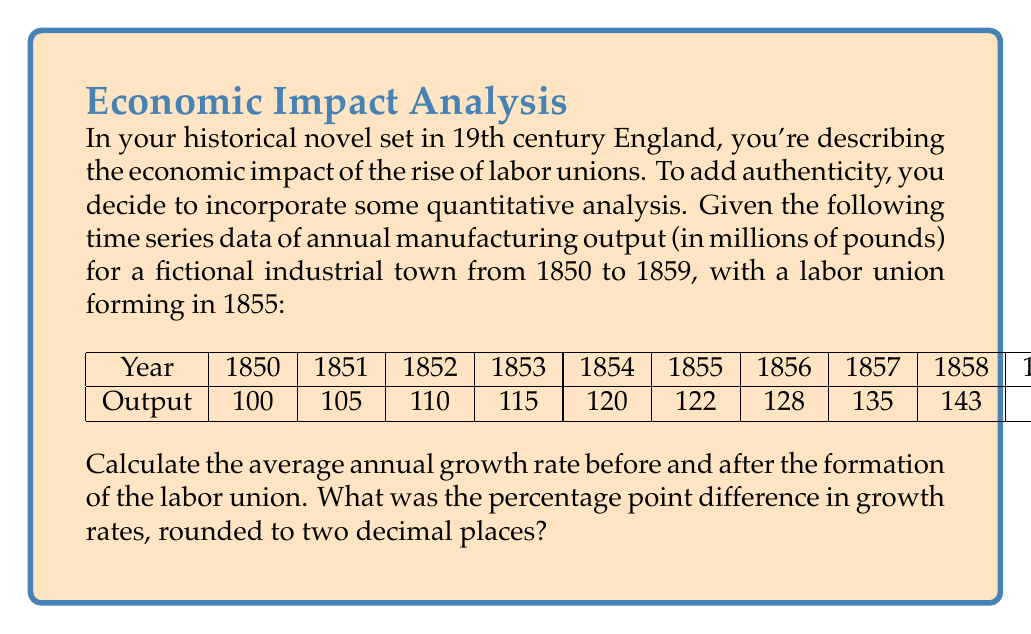Give your solution to this math problem. To solve this problem, we'll follow these steps:

1. Calculate the average annual growth rate before the union formation (1850-1854):
   Let's use the compound annual growth rate (CAGR) formula:
   $$ CAGR = \left(\frac{Ending Value}{Beginning Value}\right)^{\frac{1}{n}} - 1 $$
   Where n is the number of years.

   $$ CAGR_{before} = \left(\frac{120}{100}\right)^{\frac{1}{4}} - 1 = 0.0466 = 4.66\% $$

2. Calculate the average annual growth rate after the union formation (1855-1859):
   $$ CAGR_{after} = \left(\frac{152}{122}\right)^{\frac{1}{4}} - 1 = 0.0566 = 5.66\% $$

3. Calculate the difference in percentage points:
   Difference = $CAGR_{after} - CAGR_{before}$
   $$ 5.66\% - 4.66\% = 1.00\% $$

4. Round to two decimal places:
   1.00 percentage points

This analysis suggests that the formation of the labor union coincided with a 1.00 percentage point increase in the average annual growth rate of manufacturing output in the town.
Answer: 1.00 percentage points 